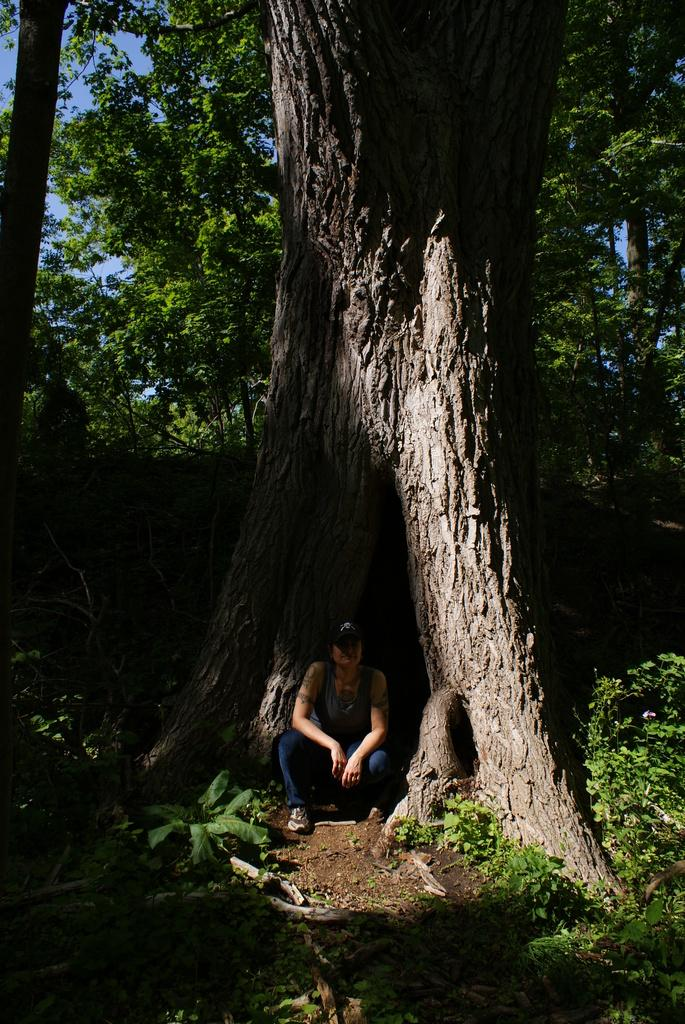What is the main subject in the center of the image? There is a person sitting in the center of the image. What can be seen in the background of the image? There are trees in the background of the image. What type of terrain is visible at the bottom of the image? There is sand and plants at the bottom of the image. What type of effect does the knife have on the bee in the image? There is no knife or bee present in the image. 